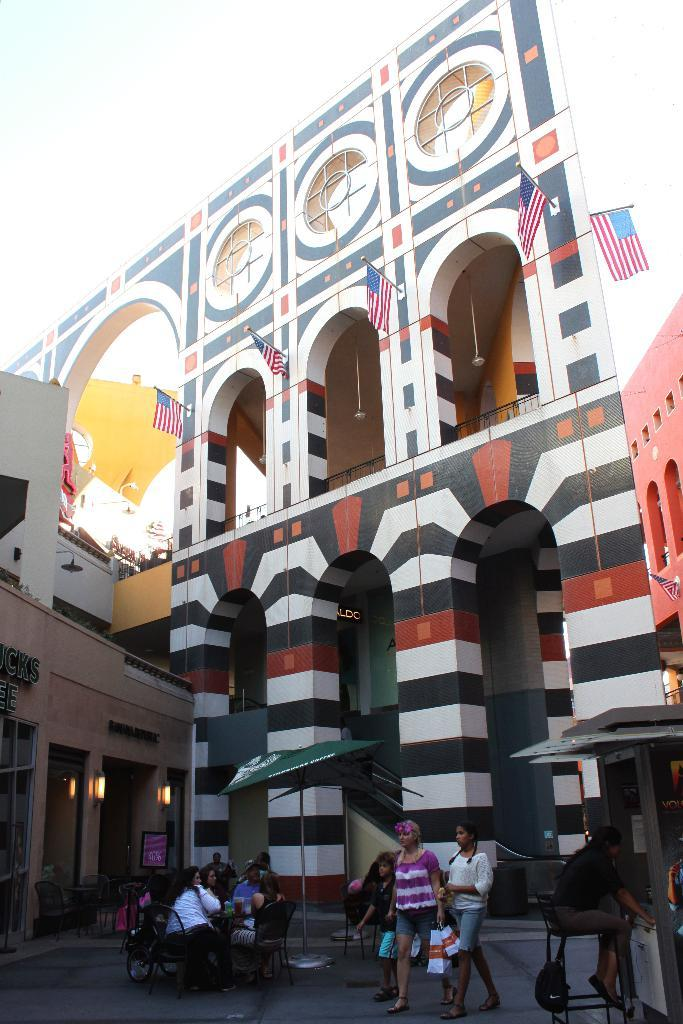What is located in the center of the image? There are flags and a building in the center of the image. What can be seen at the bottom of the image? There are umbrellas, chairs, and persons at the bottom of the image. What is visible in the background of the image? The sky is visible in the background of the image. What type of toy can be seen in the image? There is no toy present in the image. What is the color of the celery in the image? There is no celery present in the image. 